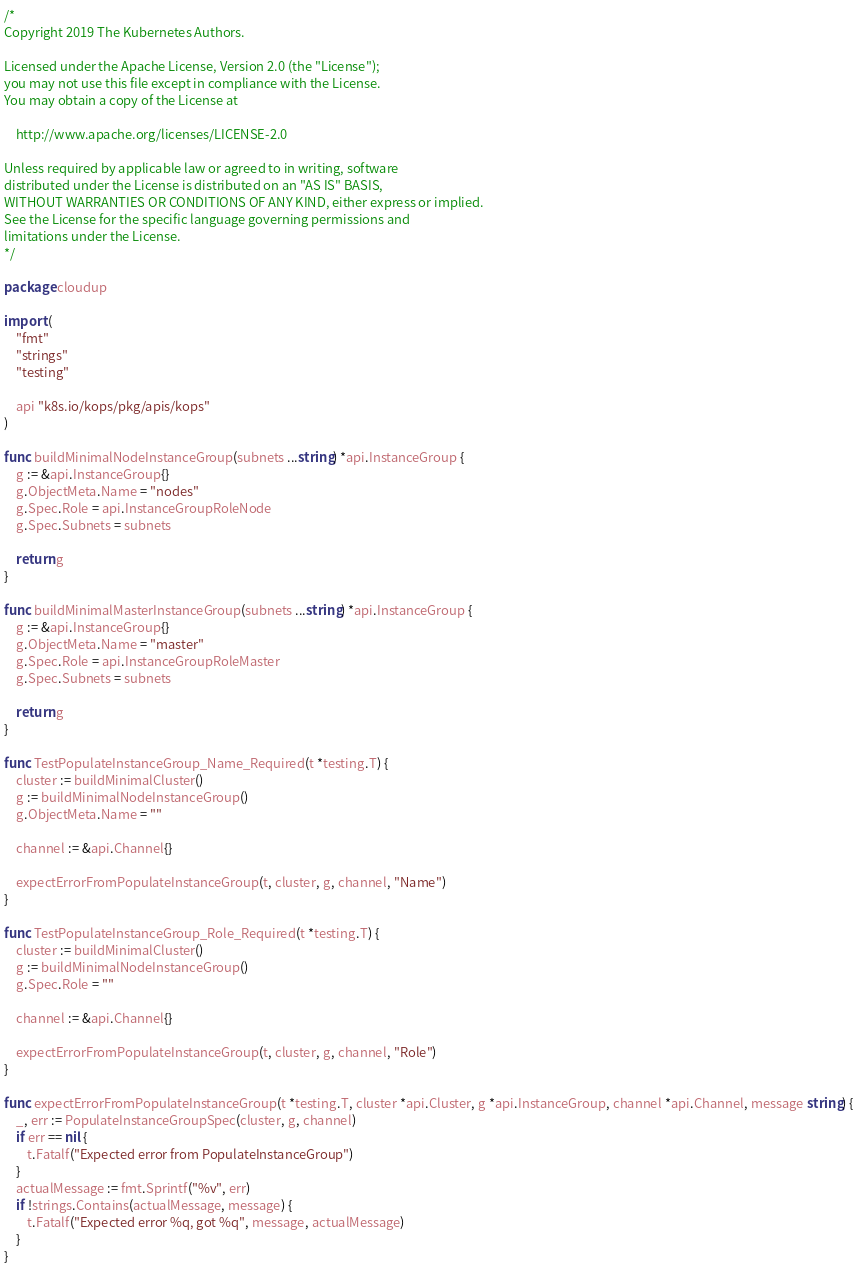<code> <loc_0><loc_0><loc_500><loc_500><_Go_>/*
Copyright 2019 The Kubernetes Authors.

Licensed under the Apache License, Version 2.0 (the "License");
you may not use this file except in compliance with the License.
You may obtain a copy of the License at

    http://www.apache.org/licenses/LICENSE-2.0

Unless required by applicable law or agreed to in writing, software
distributed under the License is distributed on an "AS IS" BASIS,
WITHOUT WARRANTIES OR CONDITIONS OF ANY KIND, either express or implied.
See the License for the specific language governing permissions and
limitations under the License.
*/

package cloudup

import (
	"fmt"
	"strings"
	"testing"

	api "k8s.io/kops/pkg/apis/kops"
)

func buildMinimalNodeInstanceGroup(subnets ...string) *api.InstanceGroup {
	g := &api.InstanceGroup{}
	g.ObjectMeta.Name = "nodes"
	g.Spec.Role = api.InstanceGroupRoleNode
	g.Spec.Subnets = subnets

	return g
}

func buildMinimalMasterInstanceGroup(subnets ...string) *api.InstanceGroup {
	g := &api.InstanceGroup{}
	g.ObjectMeta.Name = "master"
	g.Spec.Role = api.InstanceGroupRoleMaster
	g.Spec.Subnets = subnets

	return g
}

func TestPopulateInstanceGroup_Name_Required(t *testing.T) {
	cluster := buildMinimalCluster()
	g := buildMinimalNodeInstanceGroup()
	g.ObjectMeta.Name = ""

	channel := &api.Channel{}

	expectErrorFromPopulateInstanceGroup(t, cluster, g, channel, "Name")
}

func TestPopulateInstanceGroup_Role_Required(t *testing.T) {
	cluster := buildMinimalCluster()
	g := buildMinimalNodeInstanceGroup()
	g.Spec.Role = ""

	channel := &api.Channel{}

	expectErrorFromPopulateInstanceGroup(t, cluster, g, channel, "Role")
}

func expectErrorFromPopulateInstanceGroup(t *testing.T, cluster *api.Cluster, g *api.InstanceGroup, channel *api.Channel, message string) {
	_, err := PopulateInstanceGroupSpec(cluster, g, channel)
	if err == nil {
		t.Fatalf("Expected error from PopulateInstanceGroup")
	}
	actualMessage := fmt.Sprintf("%v", err)
	if !strings.Contains(actualMessage, message) {
		t.Fatalf("Expected error %q, got %q", message, actualMessage)
	}
}
</code> 